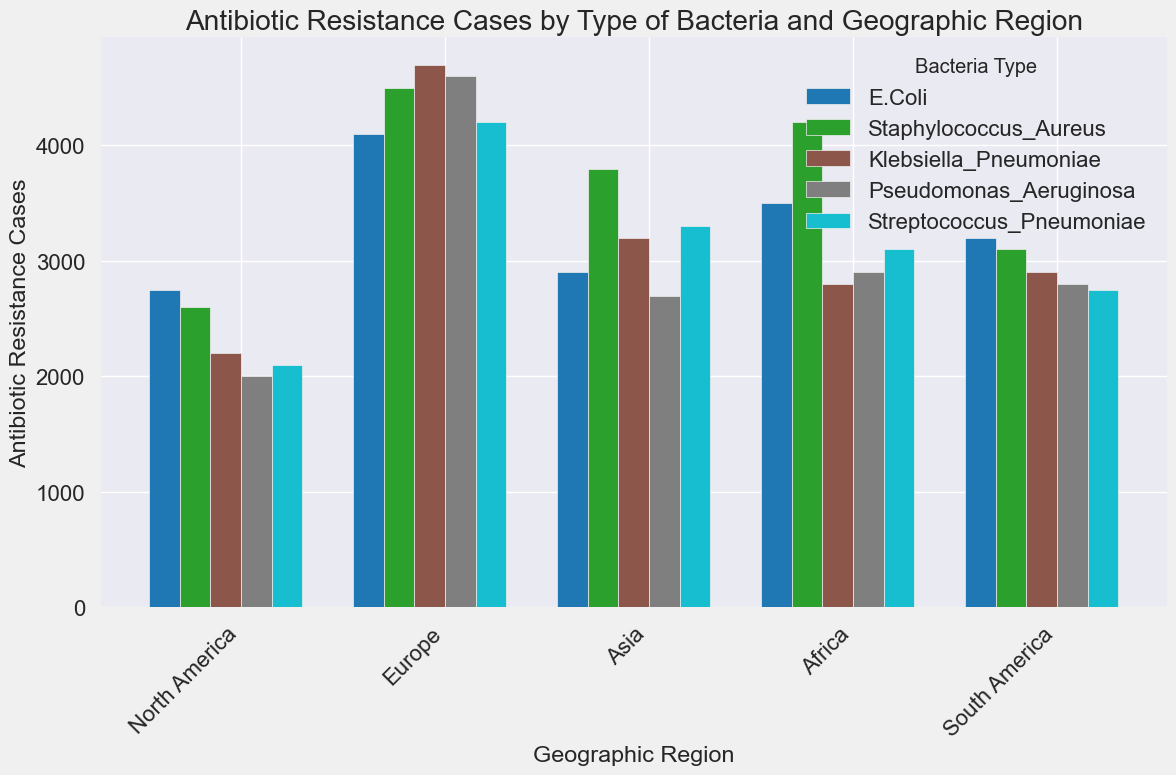Which geographic region has the highest number of antibiotic resistance cases for E. Coli? To determine this, look at the E. Coli bars across different regions and identify the highest. Asia has the tallest bar for E. Coli.
Answer: Asia Which bacteria type has the lowest number of antibiotic resistance cases in Africa? Look at the heights of all bars for Africa across different bacteria types and identify the lowest one. The Pseudomonas Aeruginosa bar is the shortest.
Answer: Pseudomonas Aeruginosa What's the difference in the number of antibiotic resistance cases caused by Klebsiella Pneumoniae between Europe and Africa? Look at the bars for Klebsiella Pneumoniae in Europe and Africa, and find the height difference. Europe has 3200 cases, and Africa has 2200 cases, so the difference is 3200 - 2200 = 1000.
Answer: 1000 How do the cases of antibiotic resistance in North America compare between E. Coli and Staphylococcus Aureus? Look at the bars for E. Coli and Staphylococcus Aureus in North America and compare their heights. Staphylococcus Aureus has a taller bar (4200 cases) than E. Coli (3500 cases).
Answer: Staphylococcus Aureus has more Which geographic region has the closest number of antibiotic resistance cases for Streptococcus Pneumoniae and E. Coli? Compare the heights of the bars for Streptococcus Pneumoniae and E. Coli across all regions. South America has 2750 cases for both Streptococcus Pneumoniae and E. Coli, which matches perfectly.
Answer: South America Which bacteria type has the most variable number of antibiotic resistance cases across different regions? Compare the range of the heights of bars for each bacteria type across all regions. Pseudomonas Aeruginosa has the largest range from 2000 (Africa) to 4600 (Asia), making it the most variable.
Answer: Pseudomonas Aeruginosa What is the average number of antibiotic resistance cases for Staphylococcus Aureus across all regions? Sum up the cases for Staphylococcus Aureus across all regions (4200 + 3800 + 4500 + 2600 + 3100 = 18200), then divide by the number of regions (5). The average is 18200 / 5 = 3640.
Answer: 3640 Which bacteria type has more cases in North America as compared to South America? Compare the heights of the bars for each bacteria type in North America with their corresponding heights in South America. Staphylococcus Aureus (4200 > 3100) and Streptococcus Pneumoniae (3100 > 2750) have more cases in North America compared to South America.
Answer: Staphylococcus Aureus and Streptococcus Pneumoniae 